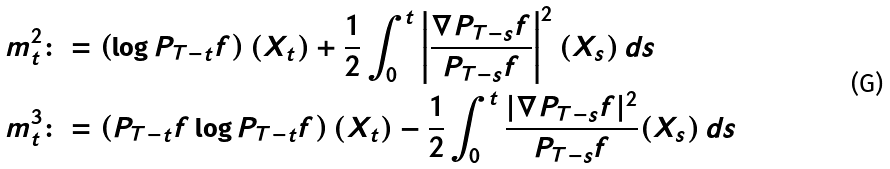<formula> <loc_0><loc_0><loc_500><loc_500>m ^ { 2 } _ { t } & \colon = \left ( \log P _ { T - t } f \right ) ( X _ { t } ) + \frac { 1 } { 2 } \int _ { 0 } ^ { t } \left | \frac { \nabla P _ { T - s } f } { P _ { T - s } f } \right | ^ { 2 } ( X _ { s } ) \, d s \\ m ^ { 3 } _ { t } & \colon = \left ( P _ { T - t } f \log P _ { T - t } f \right ) ( X _ { t } ) - \frac { 1 } { 2 } \int _ { 0 } ^ { t } \frac { | \nabla P _ { T - s } f | ^ { 2 } } { P _ { T - s } f } ( X _ { s } ) \, d s</formula> 